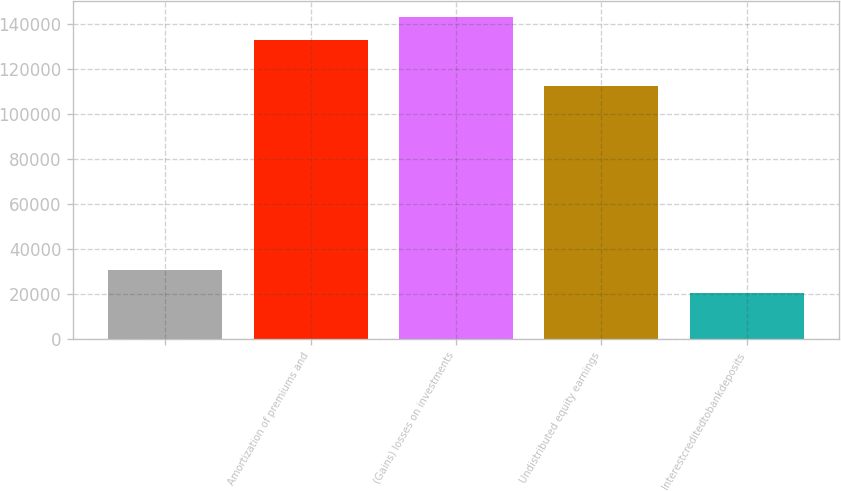<chart> <loc_0><loc_0><loc_500><loc_500><bar_chart><ecel><fcel>Amortization of premiums and<fcel>(Gains) losses on investments<fcel>Undistributed equity earnings<fcel>Interestcreditedtobankdeposits<nl><fcel>30773<fcel>132883<fcel>143094<fcel>112461<fcel>20562<nl></chart> 